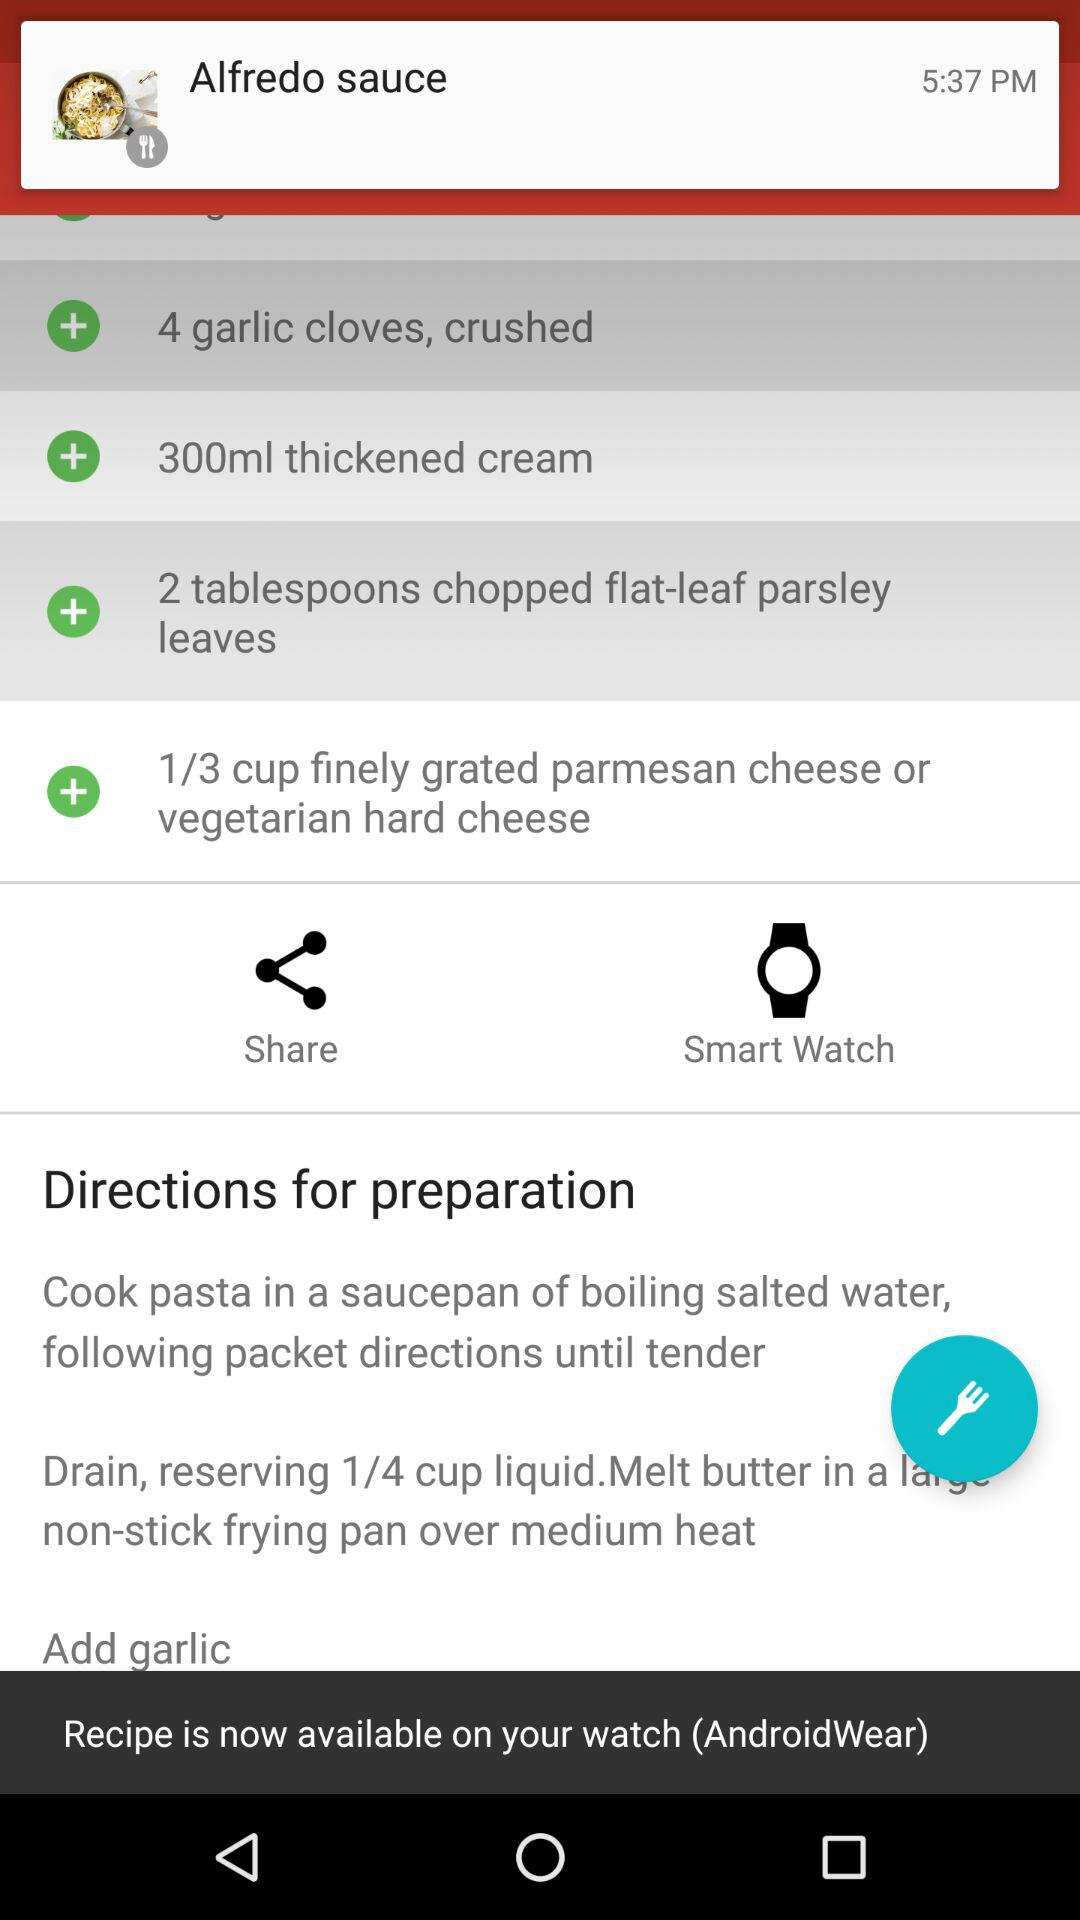How many garlic cloves are required for this recipe?
Answer the question using a single word or phrase. 4 